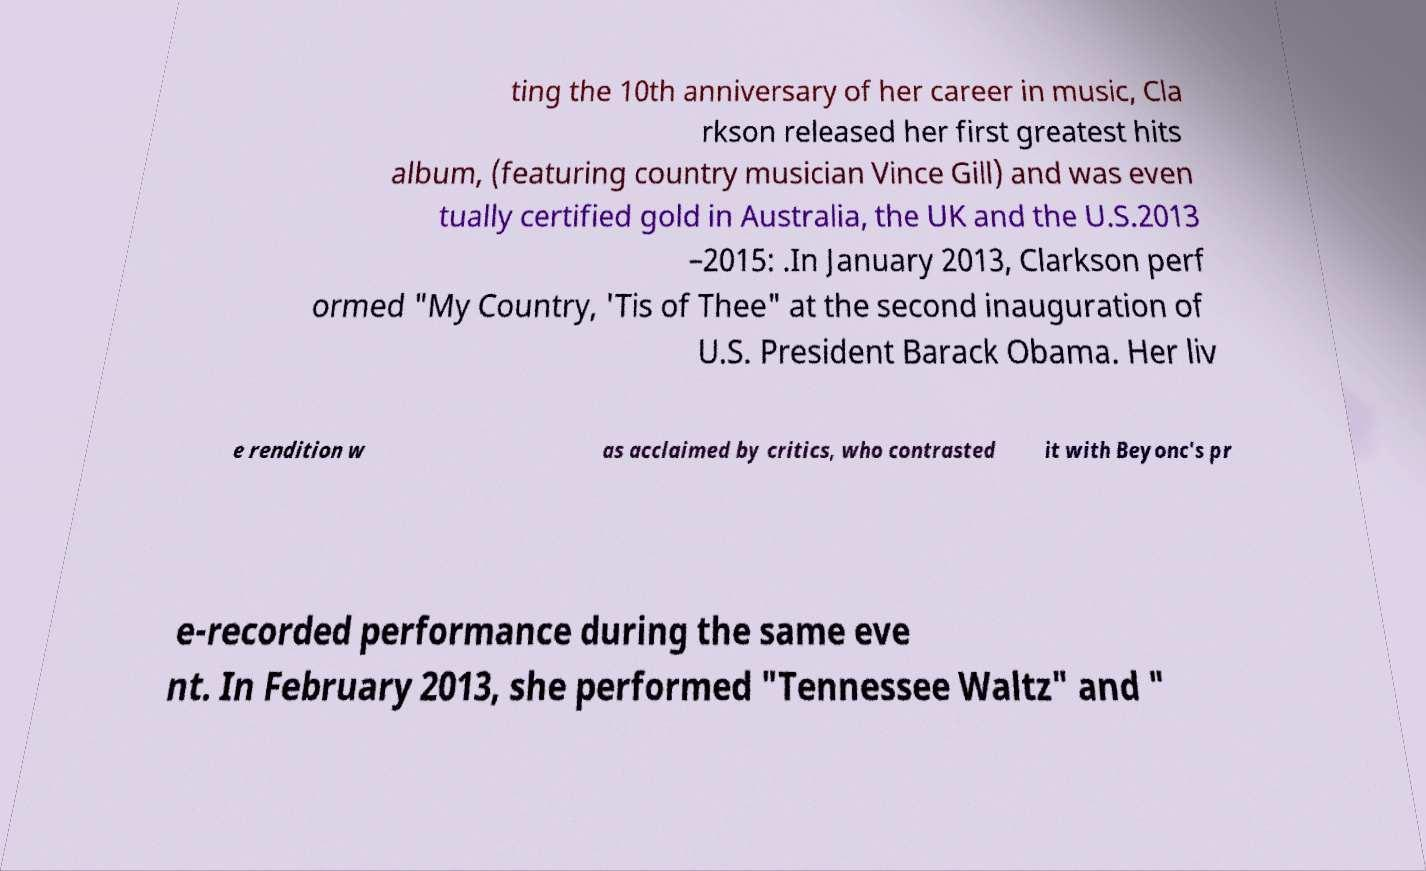There's text embedded in this image that I need extracted. Can you transcribe it verbatim? ting the 10th anniversary of her career in music, Cla rkson released her first greatest hits album, (featuring country musician Vince Gill) and was even tually certified gold in Australia, the UK and the U.S.2013 –2015: .In January 2013, Clarkson perf ormed "My Country, 'Tis of Thee" at the second inauguration of U.S. President Barack Obama. Her liv e rendition w as acclaimed by critics, who contrasted it with Beyonc's pr e-recorded performance during the same eve nt. In February 2013, she performed "Tennessee Waltz" and " 